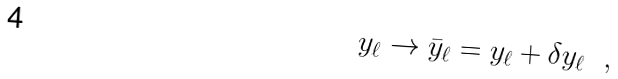Convert formula to latex. <formula><loc_0><loc_0><loc_500><loc_500>y _ { \ell } \rightarrow { \bar { y } } _ { \ell } = y _ { \ell } + \delta y _ { \ell } \ \ ,</formula> 